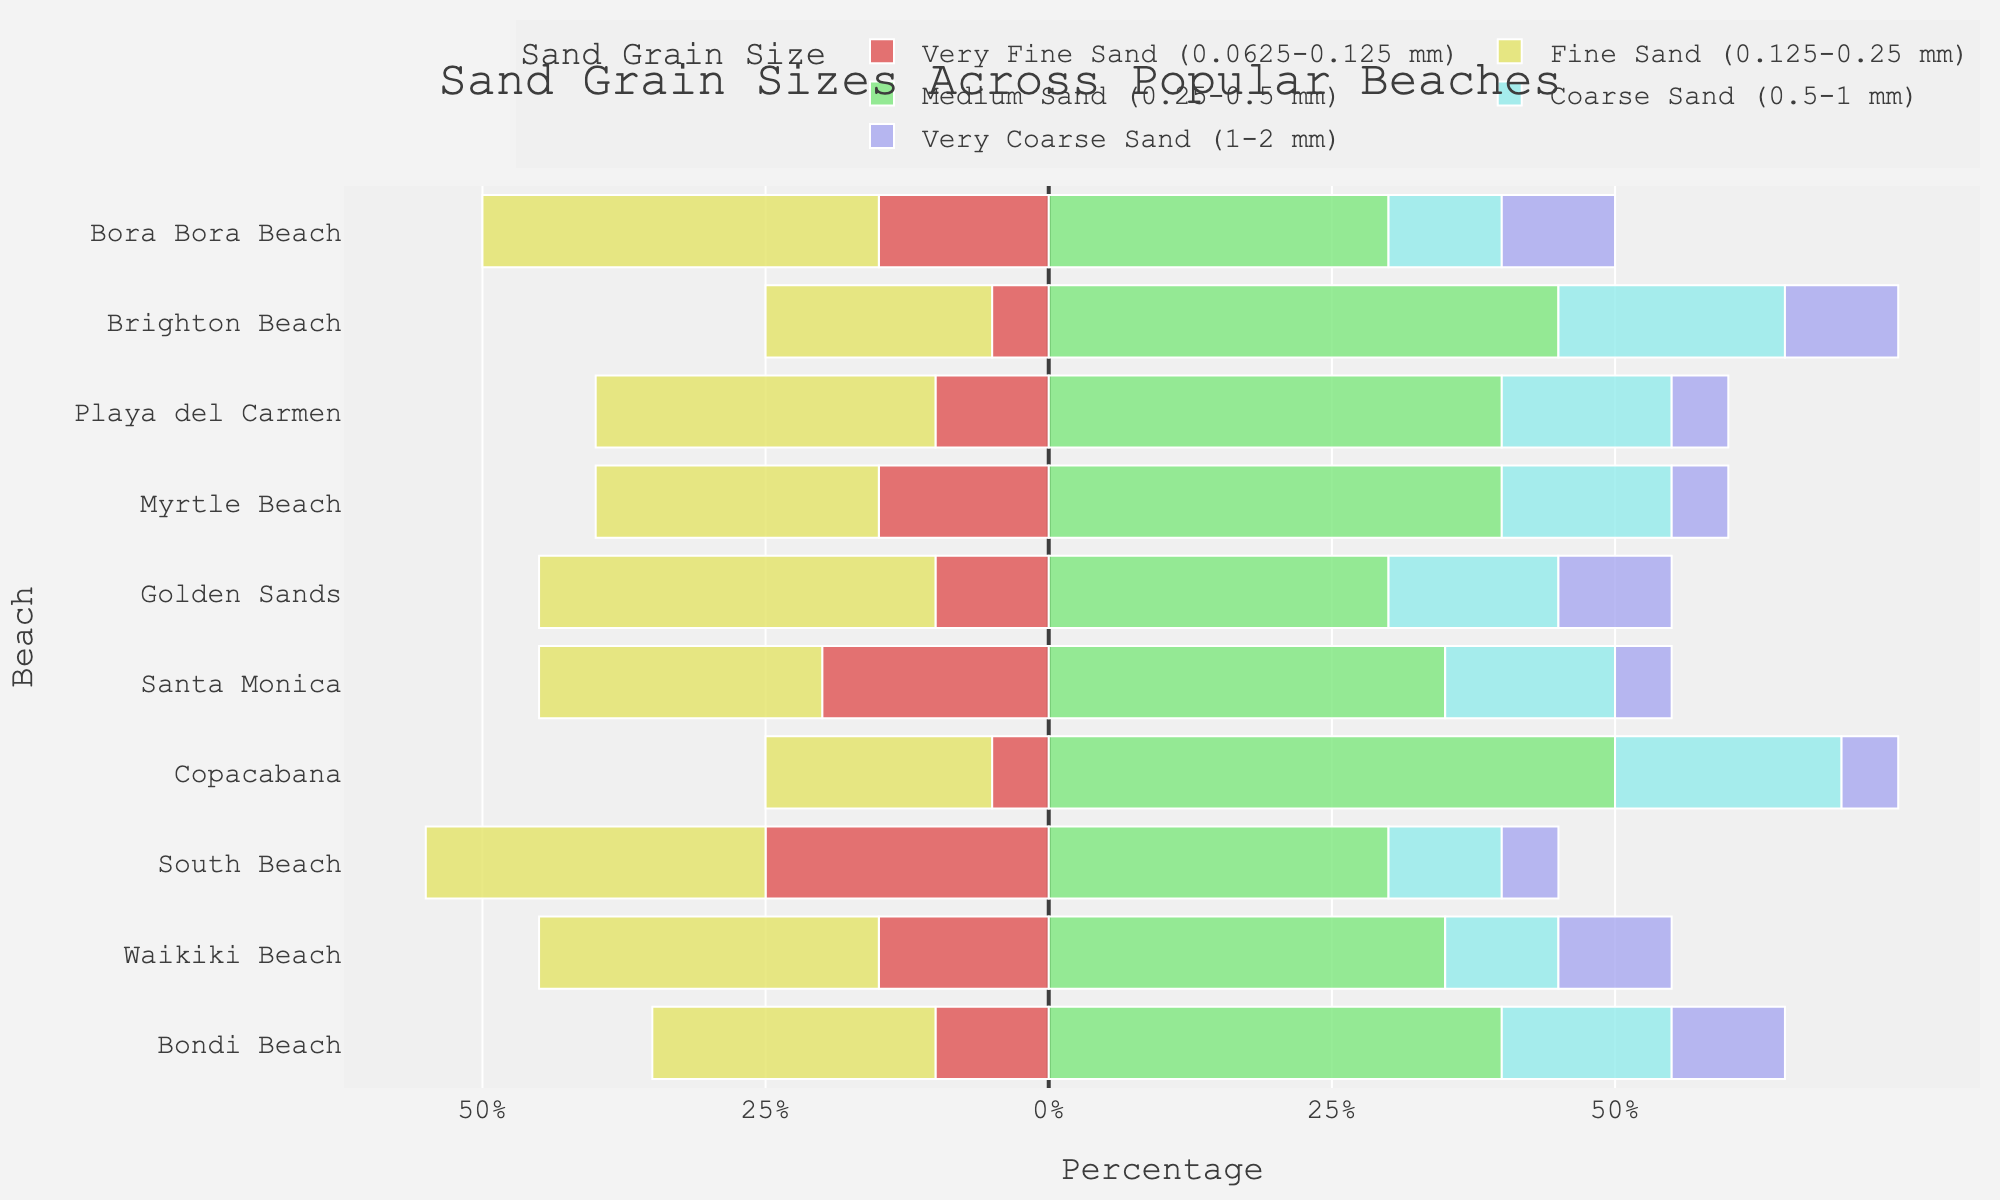Which beach has the highest proportion of very fine sand? First, locate the section for very fine sand in the diverging stacked bar chart. The bar associated with South Beach extends the farthest to the left, indicating it has the highest proportion of very fine sand.
Answer: South Beach What is the sum of fine and medium sand at Bondi Beach? Identify the fine sand and medium sand proportions for Bondi Beach; they are 25% and 40%, respectively. Add these values together: 25 + 40 = 65.
Answer: 65 How does Bora Bora Beach compare to Waikiki Beach in terms of very coarse sand? Locate the very coarse sand sections for Bora Bora Beach and Waikiki Beach. Both beaches have the same length of bars for very coarse sand, indicating they have equal proportions of 10%.
Answer: Equal Which beach has the lowest proportion of coarse sand? Identify the bar lengths for coarse sand across all beaches. The smallest bar belongs to Waikiki Beach, indicating the lowest proportion of coarse sand.
Answer: Waikiki Beach Calculate the average proportion of medium sand across all beaches. Add up the medium sand proportions for all beaches (40, 35, 30, 50, 35, 30, 40, 40, 45, 30) to get 375. There are 10 beaches, so the average is 375 / 10 = 37.5.
Answer: 37.5 Which beach has a higher proportion of fine sand, Golden Sands or Santa Monica? Compare the lengths of the bars for fine sand for Golden Sands and Santa Monica. Golden Sands has a longer bar for fine sand (35%) compared to Santa Monica (25%).
Answer: Golden Sands What is the combined proportion of coarse and very coarse sand at Copacabana? Identify the proportions of coarse and very coarse sand at Copacabana; they are 20% and 5%, respectively. Add these values together: 20 + 5 = 25.
Answer: 25 Which beach has a wider variation in sand grain sizes, Brighton Beach or Golden Sands? Consider the bars for each type of sand at Brighton Beach and Golden Sands. Brighton Beach has a wider range of proportions, especially with very fine sand (5%) and medium sand (45%); thus, it has a wider variation.
Answer: Brighton Beach What is the total proportion of all sand grain sizes at Waikiki Beach? Sum the proportions of all sand grain sizes at Waikiki Beach: 15 + 30 + 35 + 10 + 10 = 100. Since it is a full breakdown, the total proportion is 100%.
Answer: 100 Identify the beach with an equal proportion of very fine and very coarse sand. Compare the lengths of the bars for very fine sand and very coarse sand across all beaches. Both Bondi Beach and Waikiki Beach show equal proportions of these sand grain sizes; however, Bondi Beach is mentioned first.
Answer: Bondi Beach 